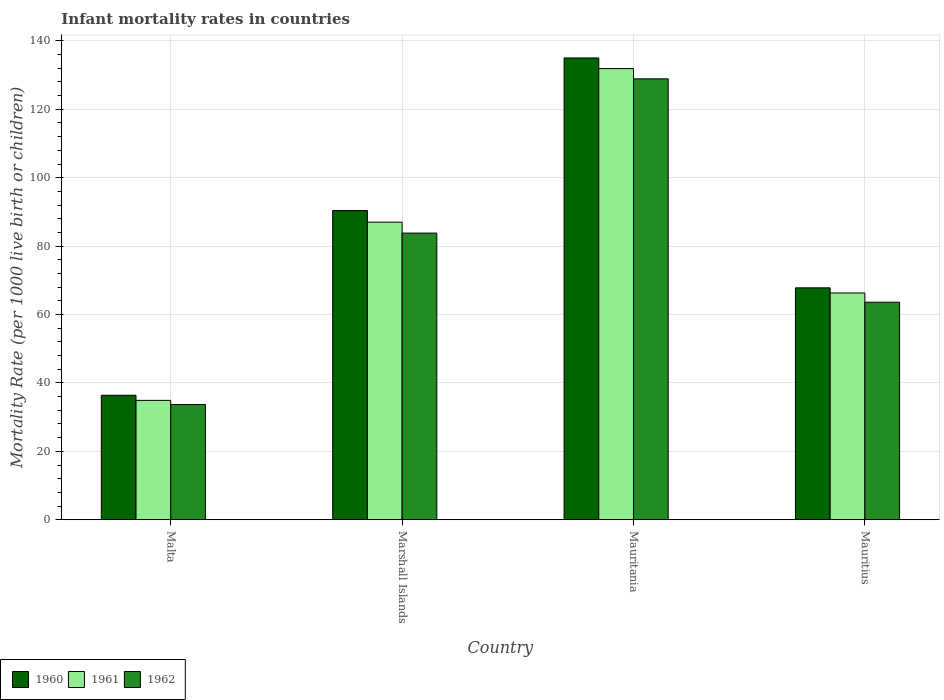Are the number of bars on each tick of the X-axis equal?
Offer a terse response. Yes. How many bars are there on the 1st tick from the left?
Offer a very short reply. 3. What is the label of the 4th group of bars from the left?
Make the answer very short. Mauritius. In how many cases, is the number of bars for a given country not equal to the number of legend labels?
Provide a succinct answer. 0. What is the infant mortality rate in 1961 in Mauritania?
Your response must be concise. 131.9. Across all countries, what is the maximum infant mortality rate in 1961?
Make the answer very short. 131.9. Across all countries, what is the minimum infant mortality rate in 1961?
Keep it short and to the point. 34.9. In which country was the infant mortality rate in 1961 maximum?
Offer a terse response. Mauritania. In which country was the infant mortality rate in 1960 minimum?
Provide a succinct answer. Malta. What is the total infant mortality rate in 1962 in the graph?
Your answer should be compact. 310. What is the difference between the infant mortality rate in 1960 in Mauritania and that in Mauritius?
Your answer should be very brief. 67.2. What is the difference between the infant mortality rate in 1961 in Marshall Islands and the infant mortality rate in 1962 in Mauritania?
Offer a very short reply. -41.9. What is the average infant mortality rate in 1960 per country?
Provide a short and direct response. 82.4. What is the difference between the infant mortality rate of/in 1961 and infant mortality rate of/in 1962 in Mauritius?
Make the answer very short. 2.7. In how many countries, is the infant mortality rate in 1962 greater than 68?
Ensure brevity in your answer.  2. What is the ratio of the infant mortality rate in 1960 in Malta to that in Mauritius?
Your response must be concise. 0.54. What is the difference between the highest and the second highest infant mortality rate in 1962?
Your response must be concise. 45.1. What is the difference between the highest and the lowest infant mortality rate in 1962?
Give a very brief answer. 95.2. What does the 2nd bar from the left in Malta represents?
Ensure brevity in your answer.  1961. What does the 1st bar from the right in Marshall Islands represents?
Offer a terse response. 1962. How many bars are there?
Provide a short and direct response. 12. Are all the bars in the graph horizontal?
Provide a short and direct response. No. How many countries are there in the graph?
Provide a succinct answer. 4. What is the difference between two consecutive major ticks on the Y-axis?
Keep it short and to the point. 20. Does the graph contain any zero values?
Your answer should be very brief. No. Does the graph contain grids?
Your answer should be compact. Yes. What is the title of the graph?
Provide a succinct answer. Infant mortality rates in countries. What is the label or title of the Y-axis?
Offer a very short reply. Mortality Rate (per 1000 live birth or children). What is the Mortality Rate (per 1000 live birth or children) of 1960 in Malta?
Keep it short and to the point. 36.4. What is the Mortality Rate (per 1000 live birth or children) in 1961 in Malta?
Your answer should be very brief. 34.9. What is the Mortality Rate (per 1000 live birth or children) of 1962 in Malta?
Your answer should be very brief. 33.7. What is the Mortality Rate (per 1000 live birth or children) in 1960 in Marshall Islands?
Provide a short and direct response. 90.4. What is the Mortality Rate (per 1000 live birth or children) in 1962 in Marshall Islands?
Provide a short and direct response. 83.8. What is the Mortality Rate (per 1000 live birth or children) in 1960 in Mauritania?
Offer a very short reply. 135. What is the Mortality Rate (per 1000 live birth or children) in 1961 in Mauritania?
Keep it short and to the point. 131.9. What is the Mortality Rate (per 1000 live birth or children) of 1962 in Mauritania?
Keep it short and to the point. 128.9. What is the Mortality Rate (per 1000 live birth or children) of 1960 in Mauritius?
Provide a short and direct response. 67.8. What is the Mortality Rate (per 1000 live birth or children) in 1961 in Mauritius?
Give a very brief answer. 66.3. What is the Mortality Rate (per 1000 live birth or children) of 1962 in Mauritius?
Your response must be concise. 63.6. Across all countries, what is the maximum Mortality Rate (per 1000 live birth or children) of 1960?
Offer a terse response. 135. Across all countries, what is the maximum Mortality Rate (per 1000 live birth or children) of 1961?
Offer a very short reply. 131.9. Across all countries, what is the maximum Mortality Rate (per 1000 live birth or children) in 1962?
Offer a very short reply. 128.9. Across all countries, what is the minimum Mortality Rate (per 1000 live birth or children) in 1960?
Offer a very short reply. 36.4. Across all countries, what is the minimum Mortality Rate (per 1000 live birth or children) in 1961?
Your response must be concise. 34.9. Across all countries, what is the minimum Mortality Rate (per 1000 live birth or children) of 1962?
Your response must be concise. 33.7. What is the total Mortality Rate (per 1000 live birth or children) in 1960 in the graph?
Make the answer very short. 329.6. What is the total Mortality Rate (per 1000 live birth or children) of 1961 in the graph?
Your response must be concise. 320.1. What is the total Mortality Rate (per 1000 live birth or children) in 1962 in the graph?
Provide a short and direct response. 310. What is the difference between the Mortality Rate (per 1000 live birth or children) of 1960 in Malta and that in Marshall Islands?
Make the answer very short. -54. What is the difference between the Mortality Rate (per 1000 live birth or children) in 1961 in Malta and that in Marshall Islands?
Provide a succinct answer. -52.1. What is the difference between the Mortality Rate (per 1000 live birth or children) in 1962 in Malta and that in Marshall Islands?
Ensure brevity in your answer.  -50.1. What is the difference between the Mortality Rate (per 1000 live birth or children) in 1960 in Malta and that in Mauritania?
Make the answer very short. -98.6. What is the difference between the Mortality Rate (per 1000 live birth or children) of 1961 in Malta and that in Mauritania?
Your answer should be compact. -97. What is the difference between the Mortality Rate (per 1000 live birth or children) of 1962 in Malta and that in Mauritania?
Make the answer very short. -95.2. What is the difference between the Mortality Rate (per 1000 live birth or children) of 1960 in Malta and that in Mauritius?
Provide a succinct answer. -31.4. What is the difference between the Mortality Rate (per 1000 live birth or children) in 1961 in Malta and that in Mauritius?
Ensure brevity in your answer.  -31.4. What is the difference between the Mortality Rate (per 1000 live birth or children) in 1962 in Malta and that in Mauritius?
Provide a short and direct response. -29.9. What is the difference between the Mortality Rate (per 1000 live birth or children) in 1960 in Marshall Islands and that in Mauritania?
Offer a very short reply. -44.6. What is the difference between the Mortality Rate (per 1000 live birth or children) in 1961 in Marshall Islands and that in Mauritania?
Your answer should be very brief. -44.9. What is the difference between the Mortality Rate (per 1000 live birth or children) of 1962 in Marshall Islands and that in Mauritania?
Offer a very short reply. -45.1. What is the difference between the Mortality Rate (per 1000 live birth or children) in 1960 in Marshall Islands and that in Mauritius?
Your answer should be very brief. 22.6. What is the difference between the Mortality Rate (per 1000 live birth or children) in 1961 in Marshall Islands and that in Mauritius?
Keep it short and to the point. 20.7. What is the difference between the Mortality Rate (per 1000 live birth or children) in 1962 in Marshall Islands and that in Mauritius?
Give a very brief answer. 20.2. What is the difference between the Mortality Rate (per 1000 live birth or children) of 1960 in Mauritania and that in Mauritius?
Make the answer very short. 67.2. What is the difference between the Mortality Rate (per 1000 live birth or children) of 1961 in Mauritania and that in Mauritius?
Offer a very short reply. 65.6. What is the difference between the Mortality Rate (per 1000 live birth or children) of 1962 in Mauritania and that in Mauritius?
Your response must be concise. 65.3. What is the difference between the Mortality Rate (per 1000 live birth or children) of 1960 in Malta and the Mortality Rate (per 1000 live birth or children) of 1961 in Marshall Islands?
Your answer should be compact. -50.6. What is the difference between the Mortality Rate (per 1000 live birth or children) in 1960 in Malta and the Mortality Rate (per 1000 live birth or children) in 1962 in Marshall Islands?
Your response must be concise. -47.4. What is the difference between the Mortality Rate (per 1000 live birth or children) of 1961 in Malta and the Mortality Rate (per 1000 live birth or children) of 1962 in Marshall Islands?
Give a very brief answer. -48.9. What is the difference between the Mortality Rate (per 1000 live birth or children) in 1960 in Malta and the Mortality Rate (per 1000 live birth or children) in 1961 in Mauritania?
Provide a short and direct response. -95.5. What is the difference between the Mortality Rate (per 1000 live birth or children) in 1960 in Malta and the Mortality Rate (per 1000 live birth or children) in 1962 in Mauritania?
Provide a short and direct response. -92.5. What is the difference between the Mortality Rate (per 1000 live birth or children) of 1961 in Malta and the Mortality Rate (per 1000 live birth or children) of 1962 in Mauritania?
Provide a short and direct response. -94. What is the difference between the Mortality Rate (per 1000 live birth or children) of 1960 in Malta and the Mortality Rate (per 1000 live birth or children) of 1961 in Mauritius?
Your answer should be compact. -29.9. What is the difference between the Mortality Rate (per 1000 live birth or children) in 1960 in Malta and the Mortality Rate (per 1000 live birth or children) in 1962 in Mauritius?
Offer a terse response. -27.2. What is the difference between the Mortality Rate (per 1000 live birth or children) of 1961 in Malta and the Mortality Rate (per 1000 live birth or children) of 1962 in Mauritius?
Your answer should be compact. -28.7. What is the difference between the Mortality Rate (per 1000 live birth or children) in 1960 in Marshall Islands and the Mortality Rate (per 1000 live birth or children) in 1961 in Mauritania?
Keep it short and to the point. -41.5. What is the difference between the Mortality Rate (per 1000 live birth or children) in 1960 in Marshall Islands and the Mortality Rate (per 1000 live birth or children) in 1962 in Mauritania?
Your answer should be compact. -38.5. What is the difference between the Mortality Rate (per 1000 live birth or children) in 1961 in Marshall Islands and the Mortality Rate (per 1000 live birth or children) in 1962 in Mauritania?
Provide a succinct answer. -41.9. What is the difference between the Mortality Rate (per 1000 live birth or children) of 1960 in Marshall Islands and the Mortality Rate (per 1000 live birth or children) of 1961 in Mauritius?
Keep it short and to the point. 24.1. What is the difference between the Mortality Rate (per 1000 live birth or children) of 1960 in Marshall Islands and the Mortality Rate (per 1000 live birth or children) of 1962 in Mauritius?
Provide a short and direct response. 26.8. What is the difference between the Mortality Rate (per 1000 live birth or children) in 1961 in Marshall Islands and the Mortality Rate (per 1000 live birth or children) in 1962 in Mauritius?
Your answer should be very brief. 23.4. What is the difference between the Mortality Rate (per 1000 live birth or children) of 1960 in Mauritania and the Mortality Rate (per 1000 live birth or children) of 1961 in Mauritius?
Make the answer very short. 68.7. What is the difference between the Mortality Rate (per 1000 live birth or children) in 1960 in Mauritania and the Mortality Rate (per 1000 live birth or children) in 1962 in Mauritius?
Offer a very short reply. 71.4. What is the difference between the Mortality Rate (per 1000 live birth or children) in 1961 in Mauritania and the Mortality Rate (per 1000 live birth or children) in 1962 in Mauritius?
Make the answer very short. 68.3. What is the average Mortality Rate (per 1000 live birth or children) in 1960 per country?
Offer a terse response. 82.4. What is the average Mortality Rate (per 1000 live birth or children) of 1961 per country?
Ensure brevity in your answer.  80.03. What is the average Mortality Rate (per 1000 live birth or children) of 1962 per country?
Offer a terse response. 77.5. What is the difference between the Mortality Rate (per 1000 live birth or children) in 1960 and Mortality Rate (per 1000 live birth or children) in 1961 in Malta?
Provide a succinct answer. 1.5. What is the difference between the Mortality Rate (per 1000 live birth or children) of 1960 and Mortality Rate (per 1000 live birth or children) of 1962 in Malta?
Your answer should be compact. 2.7. What is the difference between the Mortality Rate (per 1000 live birth or children) of 1960 and Mortality Rate (per 1000 live birth or children) of 1962 in Mauritius?
Your answer should be very brief. 4.2. What is the difference between the Mortality Rate (per 1000 live birth or children) in 1961 and Mortality Rate (per 1000 live birth or children) in 1962 in Mauritius?
Your answer should be compact. 2.7. What is the ratio of the Mortality Rate (per 1000 live birth or children) of 1960 in Malta to that in Marshall Islands?
Your response must be concise. 0.4. What is the ratio of the Mortality Rate (per 1000 live birth or children) of 1961 in Malta to that in Marshall Islands?
Keep it short and to the point. 0.4. What is the ratio of the Mortality Rate (per 1000 live birth or children) in 1962 in Malta to that in Marshall Islands?
Give a very brief answer. 0.4. What is the ratio of the Mortality Rate (per 1000 live birth or children) of 1960 in Malta to that in Mauritania?
Offer a terse response. 0.27. What is the ratio of the Mortality Rate (per 1000 live birth or children) in 1961 in Malta to that in Mauritania?
Ensure brevity in your answer.  0.26. What is the ratio of the Mortality Rate (per 1000 live birth or children) in 1962 in Malta to that in Mauritania?
Ensure brevity in your answer.  0.26. What is the ratio of the Mortality Rate (per 1000 live birth or children) in 1960 in Malta to that in Mauritius?
Ensure brevity in your answer.  0.54. What is the ratio of the Mortality Rate (per 1000 live birth or children) in 1961 in Malta to that in Mauritius?
Your response must be concise. 0.53. What is the ratio of the Mortality Rate (per 1000 live birth or children) of 1962 in Malta to that in Mauritius?
Keep it short and to the point. 0.53. What is the ratio of the Mortality Rate (per 1000 live birth or children) in 1960 in Marshall Islands to that in Mauritania?
Provide a succinct answer. 0.67. What is the ratio of the Mortality Rate (per 1000 live birth or children) in 1961 in Marshall Islands to that in Mauritania?
Offer a very short reply. 0.66. What is the ratio of the Mortality Rate (per 1000 live birth or children) of 1962 in Marshall Islands to that in Mauritania?
Your answer should be very brief. 0.65. What is the ratio of the Mortality Rate (per 1000 live birth or children) in 1960 in Marshall Islands to that in Mauritius?
Provide a succinct answer. 1.33. What is the ratio of the Mortality Rate (per 1000 live birth or children) in 1961 in Marshall Islands to that in Mauritius?
Keep it short and to the point. 1.31. What is the ratio of the Mortality Rate (per 1000 live birth or children) in 1962 in Marshall Islands to that in Mauritius?
Give a very brief answer. 1.32. What is the ratio of the Mortality Rate (per 1000 live birth or children) in 1960 in Mauritania to that in Mauritius?
Provide a short and direct response. 1.99. What is the ratio of the Mortality Rate (per 1000 live birth or children) of 1961 in Mauritania to that in Mauritius?
Offer a terse response. 1.99. What is the ratio of the Mortality Rate (per 1000 live birth or children) of 1962 in Mauritania to that in Mauritius?
Provide a succinct answer. 2.03. What is the difference between the highest and the second highest Mortality Rate (per 1000 live birth or children) of 1960?
Give a very brief answer. 44.6. What is the difference between the highest and the second highest Mortality Rate (per 1000 live birth or children) of 1961?
Make the answer very short. 44.9. What is the difference between the highest and the second highest Mortality Rate (per 1000 live birth or children) in 1962?
Offer a very short reply. 45.1. What is the difference between the highest and the lowest Mortality Rate (per 1000 live birth or children) of 1960?
Your response must be concise. 98.6. What is the difference between the highest and the lowest Mortality Rate (per 1000 live birth or children) of 1961?
Keep it short and to the point. 97. What is the difference between the highest and the lowest Mortality Rate (per 1000 live birth or children) of 1962?
Offer a very short reply. 95.2. 